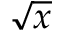Convert formula to latex. <formula><loc_0><loc_0><loc_500><loc_500>\sqrt { x }</formula> 